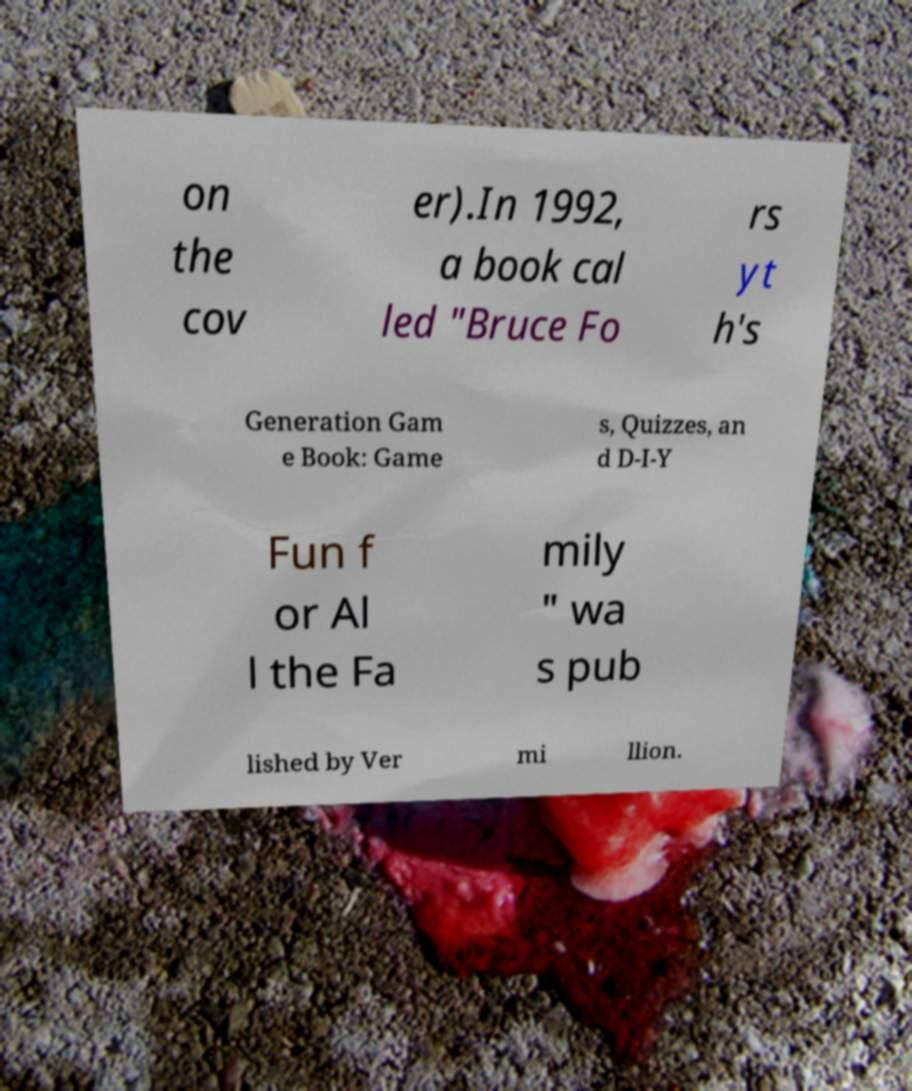Could you extract and type out the text from this image? on the cov er).In 1992, a book cal led "Bruce Fo rs yt h's Generation Gam e Book: Game s, Quizzes, an d D-I-Y Fun f or Al l the Fa mily " wa s pub lished by Ver mi llion. 